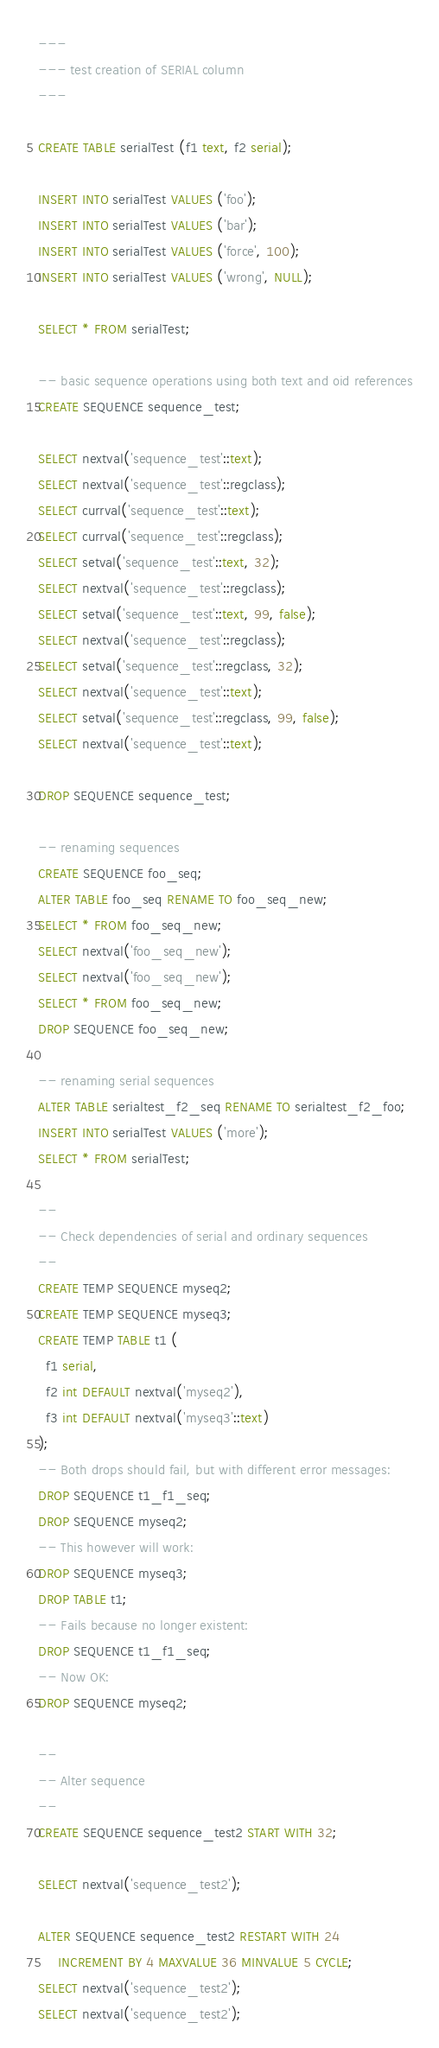<code> <loc_0><loc_0><loc_500><loc_500><_SQL_>---
--- test creation of SERIAL column
---

CREATE TABLE serialTest (f1 text, f2 serial);

INSERT INTO serialTest VALUES ('foo');
INSERT INTO serialTest VALUES ('bar');
INSERT INTO serialTest VALUES ('force', 100);
INSERT INTO serialTest VALUES ('wrong', NULL);

SELECT * FROM serialTest;

-- basic sequence operations using both text and oid references
CREATE SEQUENCE sequence_test;

SELECT nextval('sequence_test'::text);
SELECT nextval('sequence_test'::regclass);
SELECT currval('sequence_test'::text);
SELECT currval('sequence_test'::regclass);
SELECT setval('sequence_test'::text, 32);
SELECT nextval('sequence_test'::regclass);
SELECT setval('sequence_test'::text, 99, false);
SELECT nextval('sequence_test'::regclass);
SELECT setval('sequence_test'::regclass, 32);
SELECT nextval('sequence_test'::text);
SELECT setval('sequence_test'::regclass, 99, false);
SELECT nextval('sequence_test'::text);

DROP SEQUENCE sequence_test;

-- renaming sequences
CREATE SEQUENCE foo_seq;
ALTER TABLE foo_seq RENAME TO foo_seq_new;
SELECT * FROM foo_seq_new;
SELECT nextval('foo_seq_new');
SELECT nextval('foo_seq_new');
SELECT * FROM foo_seq_new;
DROP SEQUENCE foo_seq_new;

-- renaming serial sequences
ALTER TABLE serialtest_f2_seq RENAME TO serialtest_f2_foo;
INSERT INTO serialTest VALUES ('more');
SELECT * FROM serialTest;

--
-- Check dependencies of serial and ordinary sequences
--
CREATE TEMP SEQUENCE myseq2;
CREATE TEMP SEQUENCE myseq3;
CREATE TEMP TABLE t1 (
  f1 serial,
  f2 int DEFAULT nextval('myseq2'),
  f3 int DEFAULT nextval('myseq3'::text)
);
-- Both drops should fail, but with different error messages:
DROP SEQUENCE t1_f1_seq;
DROP SEQUENCE myseq2;
-- This however will work:
DROP SEQUENCE myseq3;
DROP TABLE t1;
-- Fails because no longer existent:
DROP SEQUENCE t1_f1_seq;
-- Now OK:
DROP SEQUENCE myseq2;

--
-- Alter sequence
--
CREATE SEQUENCE sequence_test2 START WITH 32;

SELECT nextval('sequence_test2');

ALTER SEQUENCE sequence_test2 RESTART WITH 24
	 INCREMENT BY 4 MAXVALUE 36 MINVALUE 5 CYCLE;
SELECT nextval('sequence_test2');
SELECT nextval('sequence_test2');</code> 